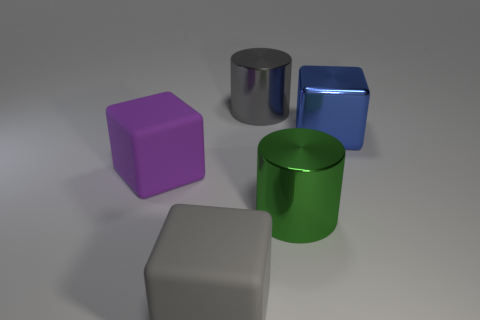Add 2 blue balls. How many objects exist? 7 Subtract all blocks. How many objects are left? 2 Add 3 purple matte spheres. How many purple matte spheres exist? 3 Subtract 0 purple balls. How many objects are left? 5 Subtract all large gray rubber balls. Subtract all blue metal things. How many objects are left? 4 Add 1 blue metallic blocks. How many blue metallic blocks are left? 2 